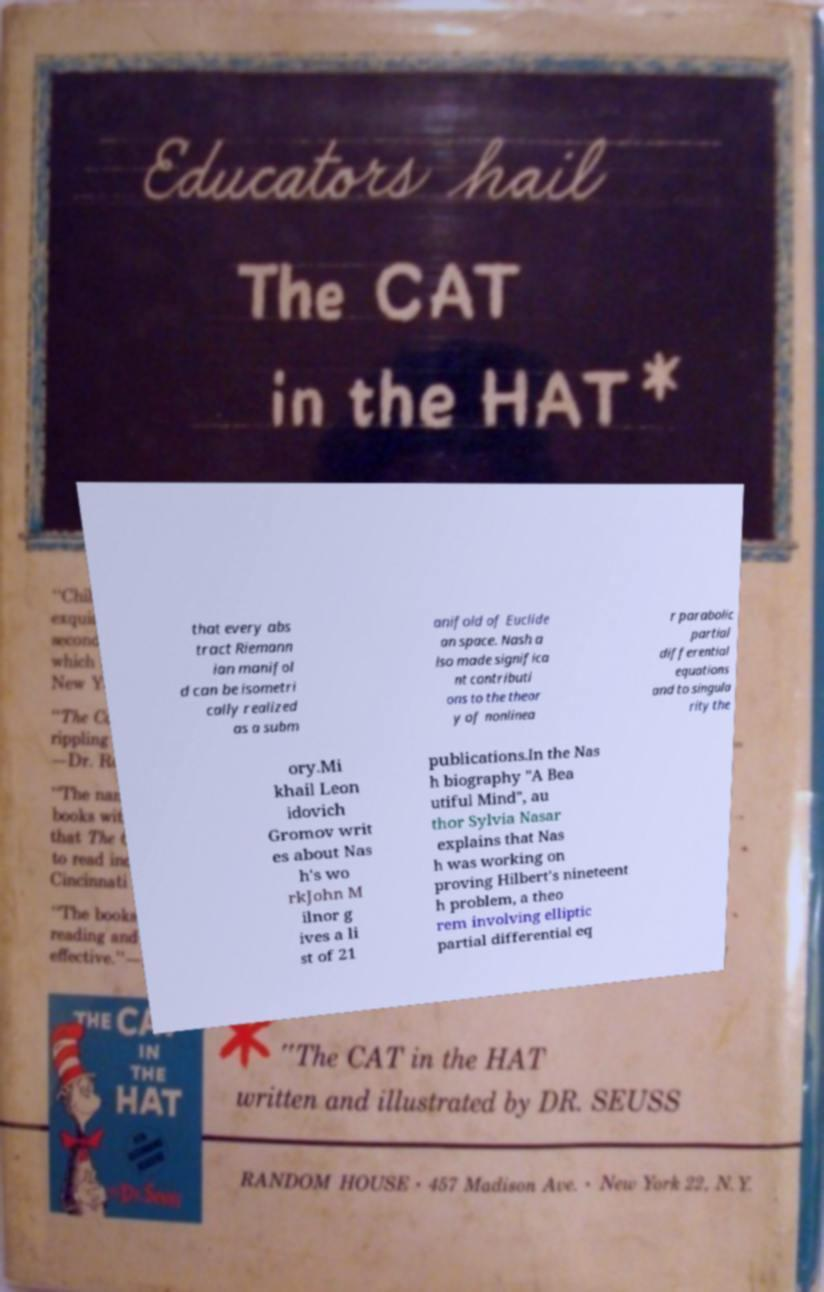Please identify and transcribe the text found in this image. that every abs tract Riemann ian manifol d can be isometri cally realized as a subm anifold of Euclide an space. Nash a lso made significa nt contributi ons to the theor y of nonlinea r parabolic partial differential equations and to singula rity the ory.Mi khail Leon idovich Gromov writ es about Nas h's wo rkJohn M ilnor g ives a li st of 21 publications.In the Nas h biography "A Bea utiful Mind", au thor Sylvia Nasar explains that Nas h was working on proving Hilbert's nineteent h problem, a theo rem involving elliptic partial differential eq 